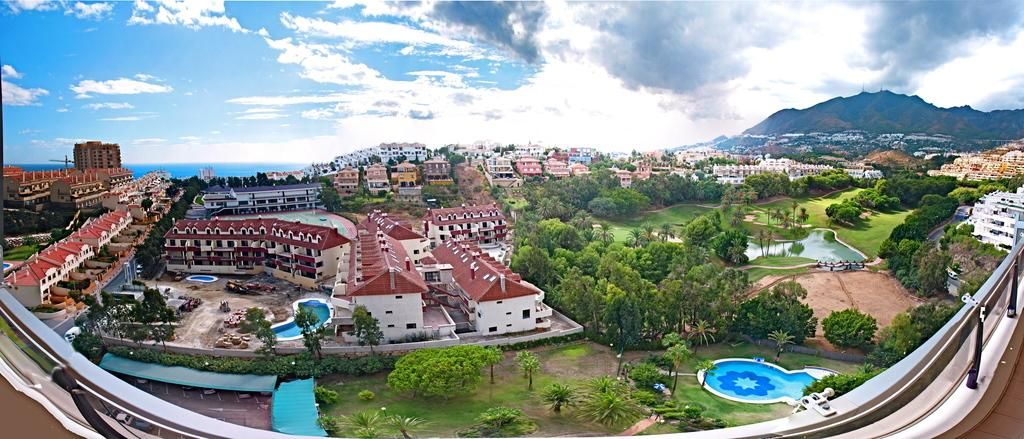What type of structures can be seen in the image? There are buildings in the image. What type of vegetation is present in the image? There are trees, plants, and grass in the image. What type of recreational facilities can be seen in the image? There are swimming pools in the image. What type of additional structures can be seen in the image? There are sheds in the image. What type of vehicles can be seen in the image? There are vehicles in the image. What can be seen in the background of the image? There are mountains and the sky in the background of the image. What is visible in the sky in the image? Clouds are present in the sky. Where is the desk located in the image? There is no desk present in the image. What channel is the door connected to in the image? There is no door or channel present in the image. 